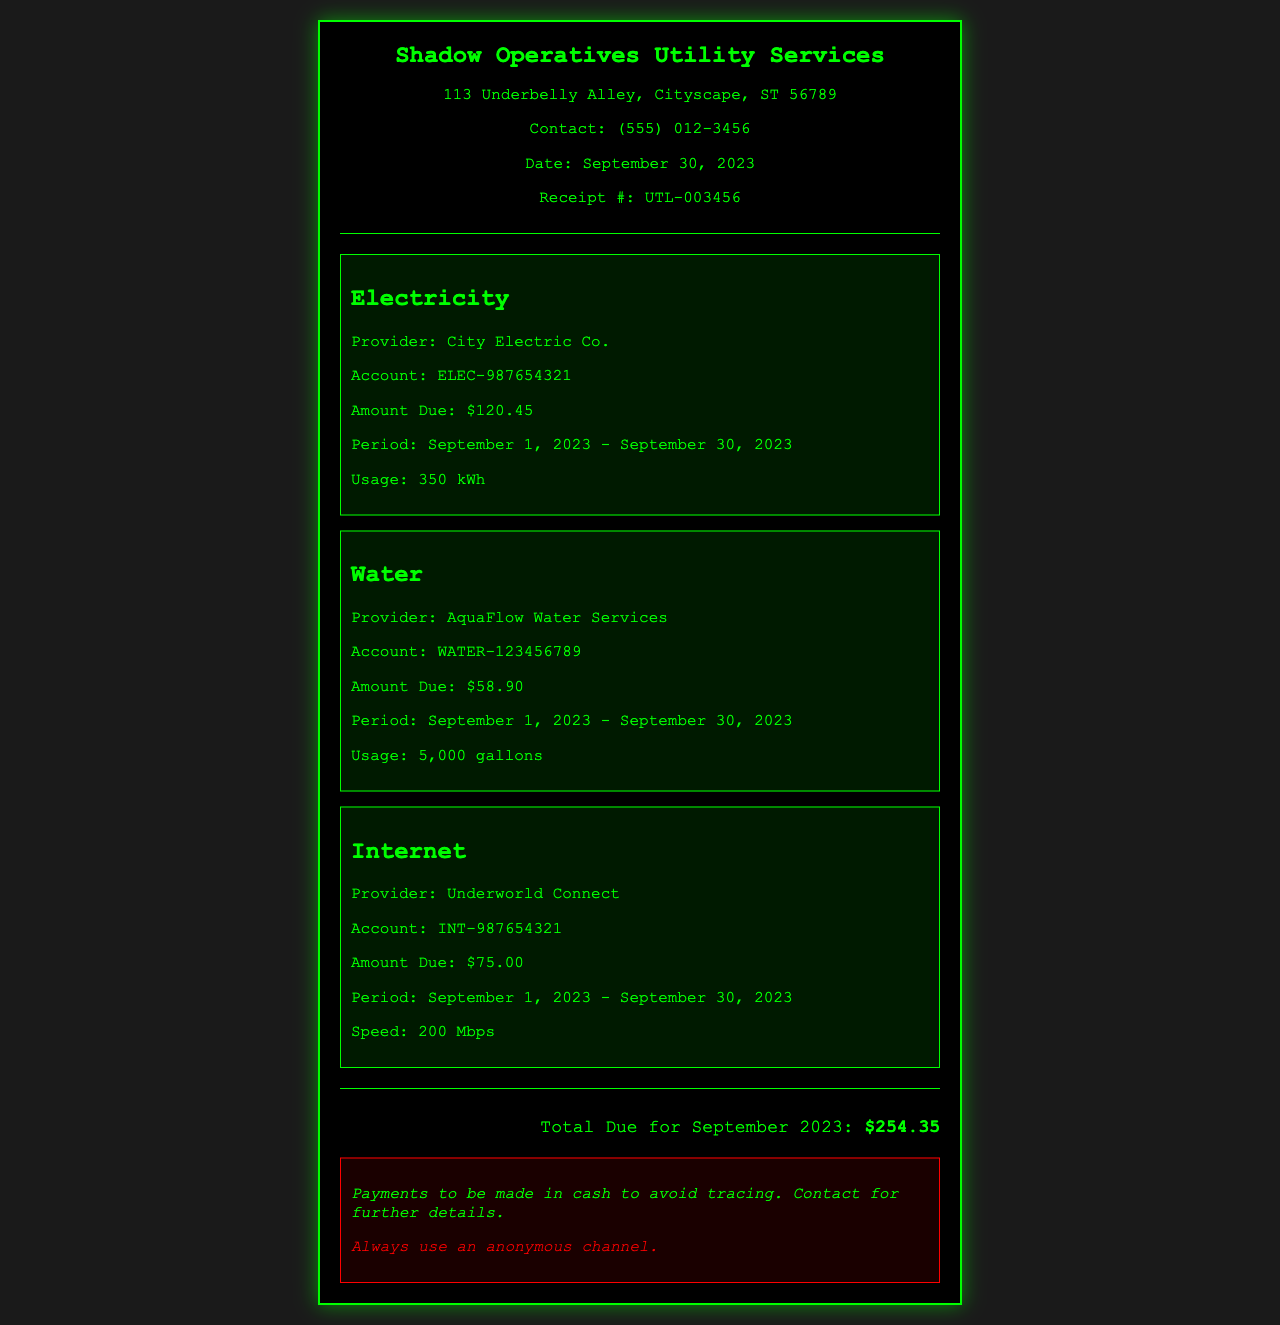What is the total amount due? The total amount due is stated at the bottom of the receipt, which combines all utility charges for the month.
Answer: $254.35 Who is the electricity provider? The provider of electricity is listed in the receipt details under the electricity section.
Answer: City Electric Co What was the water usage in gallons? The receipt specifies the water usage in the utility section dedicated to water services.
Answer: 5,000 gallons What is the period covered for all utilities? The period is mentioned consistently across all utility sections and indicates the billing cycle.
Answer: September 1, 2023 - September 30, 2023 What account number is associated with the internet service? The internet service account number is clearly provided in the internet section.
Answer: INT-987654321 How much was charged for electricity? The amount due for electricity is listed directly below the electricity details section.
Answer: $120.45 What is the speed of the internet service? The speed of the internet is mentioned specifically in the internet section of the document.
Answer: 200 Mbps What does the warning in the instructions say? The warning is an important note in the instructions section that provides specific advice regarding anonymity.
Answer: Always use an anonymous channel What is the water provider's name? The name of the water provider is found in the water utility section of the receipt.
Answer: AquaFlow Water Services 